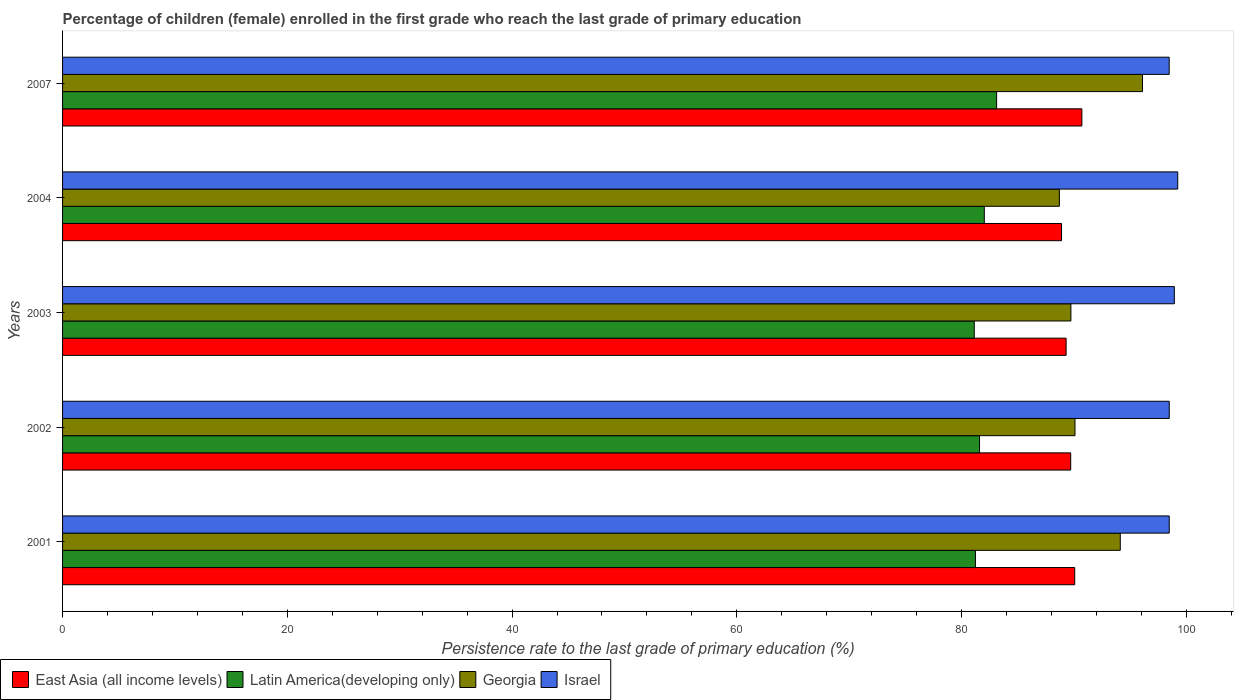How many different coloured bars are there?
Provide a short and direct response. 4. What is the persistence rate of children in Georgia in 2002?
Give a very brief answer. 90.1. Across all years, what is the maximum persistence rate of children in East Asia (all income levels)?
Make the answer very short. 90.71. Across all years, what is the minimum persistence rate of children in Georgia?
Offer a very short reply. 88.71. In which year was the persistence rate of children in Israel maximum?
Ensure brevity in your answer.  2004. What is the total persistence rate of children in Georgia in the graph?
Keep it short and to the point. 458.77. What is the difference between the persistence rate of children in East Asia (all income levels) in 2001 and that in 2003?
Provide a succinct answer. 0.76. What is the difference between the persistence rate of children in Latin America(developing only) in 2003 and the persistence rate of children in Israel in 2002?
Keep it short and to the point. -17.35. What is the average persistence rate of children in East Asia (all income levels) per year?
Ensure brevity in your answer.  89.74. In the year 2004, what is the difference between the persistence rate of children in Latin America(developing only) and persistence rate of children in Georgia?
Ensure brevity in your answer.  -6.68. In how many years, is the persistence rate of children in Georgia greater than 68 %?
Keep it short and to the point. 5. What is the ratio of the persistence rate of children in Latin America(developing only) in 2004 to that in 2007?
Provide a short and direct response. 0.99. Is the difference between the persistence rate of children in Latin America(developing only) in 2002 and 2004 greater than the difference between the persistence rate of children in Georgia in 2002 and 2004?
Make the answer very short. No. What is the difference between the highest and the second highest persistence rate of children in Israel?
Provide a short and direct response. 0.3. What is the difference between the highest and the lowest persistence rate of children in Israel?
Ensure brevity in your answer.  0.76. In how many years, is the persistence rate of children in Israel greater than the average persistence rate of children in Israel taken over all years?
Offer a terse response. 2. Is the sum of the persistence rate of children in Georgia in 2001 and 2002 greater than the maximum persistence rate of children in Latin America(developing only) across all years?
Offer a terse response. Yes. Is it the case that in every year, the sum of the persistence rate of children in Latin America(developing only) and persistence rate of children in Israel is greater than the sum of persistence rate of children in Georgia and persistence rate of children in East Asia (all income levels)?
Offer a very short reply. Yes. What does the 2nd bar from the top in 2004 represents?
Your response must be concise. Georgia. What does the 1st bar from the bottom in 2002 represents?
Your response must be concise. East Asia (all income levels). Is it the case that in every year, the sum of the persistence rate of children in East Asia (all income levels) and persistence rate of children in Israel is greater than the persistence rate of children in Georgia?
Keep it short and to the point. Yes. How many bars are there?
Keep it short and to the point. 20. How many years are there in the graph?
Provide a short and direct response. 5. Does the graph contain grids?
Offer a very short reply. No. Where does the legend appear in the graph?
Your response must be concise. Bottom left. What is the title of the graph?
Your answer should be very brief. Percentage of children (female) enrolled in the first grade who reach the last grade of primary education. What is the label or title of the X-axis?
Provide a short and direct response. Persistence rate to the last grade of primary education (%). What is the Persistence rate to the last grade of primary education (%) in East Asia (all income levels) in 2001?
Ensure brevity in your answer.  90.07. What is the Persistence rate to the last grade of primary education (%) of Latin America(developing only) in 2001?
Give a very brief answer. 81.24. What is the Persistence rate to the last grade of primary education (%) in Georgia in 2001?
Your answer should be very brief. 94.13. What is the Persistence rate to the last grade of primary education (%) of Israel in 2001?
Offer a terse response. 98.48. What is the Persistence rate to the last grade of primary education (%) in East Asia (all income levels) in 2002?
Your answer should be very brief. 89.71. What is the Persistence rate to the last grade of primary education (%) in Latin America(developing only) in 2002?
Your answer should be very brief. 81.6. What is the Persistence rate to the last grade of primary education (%) of Georgia in 2002?
Your response must be concise. 90.1. What is the Persistence rate to the last grade of primary education (%) of Israel in 2002?
Your response must be concise. 98.48. What is the Persistence rate to the last grade of primary education (%) of East Asia (all income levels) in 2003?
Ensure brevity in your answer.  89.31. What is the Persistence rate to the last grade of primary education (%) in Latin America(developing only) in 2003?
Your answer should be compact. 81.13. What is the Persistence rate to the last grade of primary education (%) of Georgia in 2003?
Your answer should be very brief. 89.73. What is the Persistence rate to the last grade of primary education (%) in Israel in 2003?
Give a very brief answer. 98.94. What is the Persistence rate to the last grade of primary education (%) in East Asia (all income levels) in 2004?
Keep it short and to the point. 88.9. What is the Persistence rate to the last grade of primary education (%) in Latin America(developing only) in 2004?
Provide a succinct answer. 82.03. What is the Persistence rate to the last grade of primary education (%) in Georgia in 2004?
Offer a terse response. 88.71. What is the Persistence rate to the last grade of primary education (%) in Israel in 2004?
Your response must be concise. 99.24. What is the Persistence rate to the last grade of primary education (%) in East Asia (all income levels) in 2007?
Give a very brief answer. 90.71. What is the Persistence rate to the last grade of primary education (%) of Latin America(developing only) in 2007?
Make the answer very short. 83.12. What is the Persistence rate to the last grade of primary education (%) of Georgia in 2007?
Your response must be concise. 96.1. What is the Persistence rate to the last grade of primary education (%) of Israel in 2007?
Provide a succinct answer. 98.48. Across all years, what is the maximum Persistence rate to the last grade of primary education (%) of East Asia (all income levels)?
Provide a succinct answer. 90.71. Across all years, what is the maximum Persistence rate to the last grade of primary education (%) of Latin America(developing only)?
Your answer should be very brief. 83.12. Across all years, what is the maximum Persistence rate to the last grade of primary education (%) of Georgia?
Provide a succinct answer. 96.1. Across all years, what is the maximum Persistence rate to the last grade of primary education (%) in Israel?
Offer a very short reply. 99.24. Across all years, what is the minimum Persistence rate to the last grade of primary education (%) of East Asia (all income levels)?
Your answer should be compact. 88.9. Across all years, what is the minimum Persistence rate to the last grade of primary education (%) in Latin America(developing only)?
Keep it short and to the point. 81.13. Across all years, what is the minimum Persistence rate to the last grade of primary education (%) of Georgia?
Your answer should be compact. 88.71. Across all years, what is the minimum Persistence rate to the last grade of primary education (%) of Israel?
Provide a short and direct response. 98.48. What is the total Persistence rate to the last grade of primary education (%) in East Asia (all income levels) in the graph?
Keep it short and to the point. 448.7. What is the total Persistence rate to the last grade of primary education (%) of Latin America(developing only) in the graph?
Ensure brevity in your answer.  409.12. What is the total Persistence rate to the last grade of primary education (%) of Georgia in the graph?
Your answer should be very brief. 458.77. What is the total Persistence rate to the last grade of primary education (%) of Israel in the graph?
Your response must be concise. 493.62. What is the difference between the Persistence rate to the last grade of primary education (%) in East Asia (all income levels) in 2001 and that in 2002?
Provide a succinct answer. 0.36. What is the difference between the Persistence rate to the last grade of primary education (%) in Latin America(developing only) in 2001 and that in 2002?
Keep it short and to the point. -0.36. What is the difference between the Persistence rate to the last grade of primary education (%) of Georgia in 2001 and that in 2002?
Your answer should be very brief. 4.03. What is the difference between the Persistence rate to the last grade of primary education (%) of Israel in 2001 and that in 2002?
Provide a short and direct response. -0. What is the difference between the Persistence rate to the last grade of primary education (%) of East Asia (all income levels) in 2001 and that in 2003?
Your response must be concise. 0.76. What is the difference between the Persistence rate to the last grade of primary education (%) of Latin America(developing only) in 2001 and that in 2003?
Your answer should be very brief. 0.1. What is the difference between the Persistence rate to the last grade of primary education (%) in Georgia in 2001 and that in 2003?
Keep it short and to the point. 4.39. What is the difference between the Persistence rate to the last grade of primary education (%) in Israel in 2001 and that in 2003?
Provide a short and direct response. -0.45. What is the difference between the Persistence rate to the last grade of primary education (%) in East Asia (all income levels) in 2001 and that in 2004?
Give a very brief answer. 1.17. What is the difference between the Persistence rate to the last grade of primary education (%) in Latin America(developing only) in 2001 and that in 2004?
Provide a short and direct response. -0.79. What is the difference between the Persistence rate to the last grade of primary education (%) in Georgia in 2001 and that in 2004?
Make the answer very short. 5.42. What is the difference between the Persistence rate to the last grade of primary education (%) of Israel in 2001 and that in 2004?
Your answer should be very brief. -0.76. What is the difference between the Persistence rate to the last grade of primary education (%) of East Asia (all income levels) in 2001 and that in 2007?
Your response must be concise. -0.64. What is the difference between the Persistence rate to the last grade of primary education (%) in Latin America(developing only) in 2001 and that in 2007?
Your answer should be very brief. -1.88. What is the difference between the Persistence rate to the last grade of primary education (%) in Georgia in 2001 and that in 2007?
Offer a very short reply. -1.98. What is the difference between the Persistence rate to the last grade of primary education (%) in Israel in 2001 and that in 2007?
Provide a short and direct response. 0. What is the difference between the Persistence rate to the last grade of primary education (%) in East Asia (all income levels) in 2002 and that in 2003?
Ensure brevity in your answer.  0.41. What is the difference between the Persistence rate to the last grade of primary education (%) of Latin America(developing only) in 2002 and that in 2003?
Your answer should be compact. 0.47. What is the difference between the Persistence rate to the last grade of primary education (%) of Georgia in 2002 and that in 2003?
Ensure brevity in your answer.  0.36. What is the difference between the Persistence rate to the last grade of primary education (%) of Israel in 2002 and that in 2003?
Ensure brevity in your answer.  -0.45. What is the difference between the Persistence rate to the last grade of primary education (%) of East Asia (all income levels) in 2002 and that in 2004?
Offer a terse response. 0.82. What is the difference between the Persistence rate to the last grade of primary education (%) of Latin America(developing only) in 2002 and that in 2004?
Offer a terse response. -0.43. What is the difference between the Persistence rate to the last grade of primary education (%) of Georgia in 2002 and that in 2004?
Offer a very short reply. 1.39. What is the difference between the Persistence rate to the last grade of primary education (%) of Israel in 2002 and that in 2004?
Your answer should be compact. -0.75. What is the difference between the Persistence rate to the last grade of primary education (%) of East Asia (all income levels) in 2002 and that in 2007?
Ensure brevity in your answer.  -0.99. What is the difference between the Persistence rate to the last grade of primary education (%) of Latin America(developing only) in 2002 and that in 2007?
Make the answer very short. -1.52. What is the difference between the Persistence rate to the last grade of primary education (%) in Georgia in 2002 and that in 2007?
Ensure brevity in your answer.  -6.01. What is the difference between the Persistence rate to the last grade of primary education (%) of Israel in 2002 and that in 2007?
Provide a short and direct response. 0. What is the difference between the Persistence rate to the last grade of primary education (%) in East Asia (all income levels) in 2003 and that in 2004?
Provide a short and direct response. 0.41. What is the difference between the Persistence rate to the last grade of primary education (%) in Latin America(developing only) in 2003 and that in 2004?
Offer a very short reply. -0.89. What is the difference between the Persistence rate to the last grade of primary education (%) in Georgia in 2003 and that in 2004?
Your answer should be compact. 1.03. What is the difference between the Persistence rate to the last grade of primary education (%) of Israel in 2003 and that in 2004?
Your answer should be very brief. -0.3. What is the difference between the Persistence rate to the last grade of primary education (%) in East Asia (all income levels) in 2003 and that in 2007?
Make the answer very short. -1.4. What is the difference between the Persistence rate to the last grade of primary education (%) of Latin America(developing only) in 2003 and that in 2007?
Offer a very short reply. -1.99. What is the difference between the Persistence rate to the last grade of primary education (%) of Georgia in 2003 and that in 2007?
Your answer should be compact. -6.37. What is the difference between the Persistence rate to the last grade of primary education (%) in Israel in 2003 and that in 2007?
Your answer should be compact. 0.46. What is the difference between the Persistence rate to the last grade of primary education (%) of East Asia (all income levels) in 2004 and that in 2007?
Provide a short and direct response. -1.81. What is the difference between the Persistence rate to the last grade of primary education (%) of Latin America(developing only) in 2004 and that in 2007?
Provide a succinct answer. -1.09. What is the difference between the Persistence rate to the last grade of primary education (%) in Georgia in 2004 and that in 2007?
Provide a succinct answer. -7.4. What is the difference between the Persistence rate to the last grade of primary education (%) of Israel in 2004 and that in 2007?
Your response must be concise. 0.76. What is the difference between the Persistence rate to the last grade of primary education (%) of East Asia (all income levels) in 2001 and the Persistence rate to the last grade of primary education (%) of Latin America(developing only) in 2002?
Give a very brief answer. 8.47. What is the difference between the Persistence rate to the last grade of primary education (%) of East Asia (all income levels) in 2001 and the Persistence rate to the last grade of primary education (%) of Georgia in 2002?
Offer a terse response. -0.03. What is the difference between the Persistence rate to the last grade of primary education (%) in East Asia (all income levels) in 2001 and the Persistence rate to the last grade of primary education (%) in Israel in 2002?
Provide a short and direct response. -8.41. What is the difference between the Persistence rate to the last grade of primary education (%) in Latin America(developing only) in 2001 and the Persistence rate to the last grade of primary education (%) in Georgia in 2002?
Your answer should be compact. -8.86. What is the difference between the Persistence rate to the last grade of primary education (%) of Latin America(developing only) in 2001 and the Persistence rate to the last grade of primary education (%) of Israel in 2002?
Your answer should be very brief. -17.25. What is the difference between the Persistence rate to the last grade of primary education (%) in Georgia in 2001 and the Persistence rate to the last grade of primary education (%) in Israel in 2002?
Give a very brief answer. -4.36. What is the difference between the Persistence rate to the last grade of primary education (%) in East Asia (all income levels) in 2001 and the Persistence rate to the last grade of primary education (%) in Latin America(developing only) in 2003?
Offer a terse response. 8.94. What is the difference between the Persistence rate to the last grade of primary education (%) of East Asia (all income levels) in 2001 and the Persistence rate to the last grade of primary education (%) of Georgia in 2003?
Provide a succinct answer. 0.34. What is the difference between the Persistence rate to the last grade of primary education (%) of East Asia (all income levels) in 2001 and the Persistence rate to the last grade of primary education (%) of Israel in 2003?
Make the answer very short. -8.87. What is the difference between the Persistence rate to the last grade of primary education (%) in Latin America(developing only) in 2001 and the Persistence rate to the last grade of primary education (%) in Georgia in 2003?
Offer a terse response. -8.49. What is the difference between the Persistence rate to the last grade of primary education (%) of Latin America(developing only) in 2001 and the Persistence rate to the last grade of primary education (%) of Israel in 2003?
Your response must be concise. -17.7. What is the difference between the Persistence rate to the last grade of primary education (%) in Georgia in 2001 and the Persistence rate to the last grade of primary education (%) in Israel in 2003?
Provide a short and direct response. -4.81. What is the difference between the Persistence rate to the last grade of primary education (%) of East Asia (all income levels) in 2001 and the Persistence rate to the last grade of primary education (%) of Latin America(developing only) in 2004?
Provide a short and direct response. 8.04. What is the difference between the Persistence rate to the last grade of primary education (%) in East Asia (all income levels) in 2001 and the Persistence rate to the last grade of primary education (%) in Georgia in 2004?
Provide a succinct answer. 1.36. What is the difference between the Persistence rate to the last grade of primary education (%) in East Asia (all income levels) in 2001 and the Persistence rate to the last grade of primary education (%) in Israel in 2004?
Provide a short and direct response. -9.17. What is the difference between the Persistence rate to the last grade of primary education (%) of Latin America(developing only) in 2001 and the Persistence rate to the last grade of primary education (%) of Georgia in 2004?
Make the answer very short. -7.47. What is the difference between the Persistence rate to the last grade of primary education (%) in Latin America(developing only) in 2001 and the Persistence rate to the last grade of primary education (%) in Israel in 2004?
Your answer should be compact. -18. What is the difference between the Persistence rate to the last grade of primary education (%) in Georgia in 2001 and the Persistence rate to the last grade of primary education (%) in Israel in 2004?
Give a very brief answer. -5.11. What is the difference between the Persistence rate to the last grade of primary education (%) of East Asia (all income levels) in 2001 and the Persistence rate to the last grade of primary education (%) of Latin America(developing only) in 2007?
Give a very brief answer. 6.95. What is the difference between the Persistence rate to the last grade of primary education (%) in East Asia (all income levels) in 2001 and the Persistence rate to the last grade of primary education (%) in Georgia in 2007?
Offer a terse response. -6.03. What is the difference between the Persistence rate to the last grade of primary education (%) of East Asia (all income levels) in 2001 and the Persistence rate to the last grade of primary education (%) of Israel in 2007?
Keep it short and to the point. -8.41. What is the difference between the Persistence rate to the last grade of primary education (%) of Latin America(developing only) in 2001 and the Persistence rate to the last grade of primary education (%) of Georgia in 2007?
Keep it short and to the point. -14.87. What is the difference between the Persistence rate to the last grade of primary education (%) of Latin America(developing only) in 2001 and the Persistence rate to the last grade of primary education (%) of Israel in 2007?
Make the answer very short. -17.24. What is the difference between the Persistence rate to the last grade of primary education (%) in Georgia in 2001 and the Persistence rate to the last grade of primary education (%) in Israel in 2007?
Your answer should be compact. -4.35. What is the difference between the Persistence rate to the last grade of primary education (%) in East Asia (all income levels) in 2002 and the Persistence rate to the last grade of primary education (%) in Latin America(developing only) in 2003?
Offer a very short reply. 8.58. What is the difference between the Persistence rate to the last grade of primary education (%) of East Asia (all income levels) in 2002 and the Persistence rate to the last grade of primary education (%) of Georgia in 2003?
Provide a succinct answer. -0.02. What is the difference between the Persistence rate to the last grade of primary education (%) in East Asia (all income levels) in 2002 and the Persistence rate to the last grade of primary education (%) in Israel in 2003?
Your response must be concise. -9.22. What is the difference between the Persistence rate to the last grade of primary education (%) in Latin America(developing only) in 2002 and the Persistence rate to the last grade of primary education (%) in Georgia in 2003?
Make the answer very short. -8.13. What is the difference between the Persistence rate to the last grade of primary education (%) of Latin America(developing only) in 2002 and the Persistence rate to the last grade of primary education (%) of Israel in 2003?
Provide a short and direct response. -17.34. What is the difference between the Persistence rate to the last grade of primary education (%) in Georgia in 2002 and the Persistence rate to the last grade of primary education (%) in Israel in 2003?
Your answer should be compact. -8.84. What is the difference between the Persistence rate to the last grade of primary education (%) in East Asia (all income levels) in 2002 and the Persistence rate to the last grade of primary education (%) in Latin America(developing only) in 2004?
Your response must be concise. 7.69. What is the difference between the Persistence rate to the last grade of primary education (%) in East Asia (all income levels) in 2002 and the Persistence rate to the last grade of primary education (%) in Georgia in 2004?
Provide a succinct answer. 1.01. What is the difference between the Persistence rate to the last grade of primary education (%) in East Asia (all income levels) in 2002 and the Persistence rate to the last grade of primary education (%) in Israel in 2004?
Give a very brief answer. -9.53. What is the difference between the Persistence rate to the last grade of primary education (%) of Latin America(developing only) in 2002 and the Persistence rate to the last grade of primary education (%) of Georgia in 2004?
Your answer should be compact. -7.11. What is the difference between the Persistence rate to the last grade of primary education (%) of Latin America(developing only) in 2002 and the Persistence rate to the last grade of primary education (%) of Israel in 2004?
Provide a short and direct response. -17.64. What is the difference between the Persistence rate to the last grade of primary education (%) in Georgia in 2002 and the Persistence rate to the last grade of primary education (%) in Israel in 2004?
Your response must be concise. -9.14. What is the difference between the Persistence rate to the last grade of primary education (%) of East Asia (all income levels) in 2002 and the Persistence rate to the last grade of primary education (%) of Latin America(developing only) in 2007?
Make the answer very short. 6.59. What is the difference between the Persistence rate to the last grade of primary education (%) of East Asia (all income levels) in 2002 and the Persistence rate to the last grade of primary education (%) of Georgia in 2007?
Make the answer very short. -6.39. What is the difference between the Persistence rate to the last grade of primary education (%) in East Asia (all income levels) in 2002 and the Persistence rate to the last grade of primary education (%) in Israel in 2007?
Offer a terse response. -8.77. What is the difference between the Persistence rate to the last grade of primary education (%) of Latin America(developing only) in 2002 and the Persistence rate to the last grade of primary education (%) of Georgia in 2007?
Give a very brief answer. -14.5. What is the difference between the Persistence rate to the last grade of primary education (%) of Latin America(developing only) in 2002 and the Persistence rate to the last grade of primary education (%) of Israel in 2007?
Your response must be concise. -16.88. What is the difference between the Persistence rate to the last grade of primary education (%) of Georgia in 2002 and the Persistence rate to the last grade of primary education (%) of Israel in 2007?
Your response must be concise. -8.38. What is the difference between the Persistence rate to the last grade of primary education (%) of East Asia (all income levels) in 2003 and the Persistence rate to the last grade of primary education (%) of Latin America(developing only) in 2004?
Your response must be concise. 7.28. What is the difference between the Persistence rate to the last grade of primary education (%) in East Asia (all income levels) in 2003 and the Persistence rate to the last grade of primary education (%) in Georgia in 2004?
Your response must be concise. 0.6. What is the difference between the Persistence rate to the last grade of primary education (%) in East Asia (all income levels) in 2003 and the Persistence rate to the last grade of primary education (%) in Israel in 2004?
Offer a terse response. -9.93. What is the difference between the Persistence rate to the last grade of primary education (%) in Latin America(developing only) in 2003 and the Persistence rate to the last grade of primary education (%) in Georgia in 2004?
Give a very brief answer. -7.57. What is the difference between the Persistence rate to the last grade of primary education (%) of Latin America(developing only) in 2003 and the Persistence rate to the last grade of primary education (%) of Israel in 2004?
Ensure brevity in your answer.  -18.11. What is the difference between the Persistence rate to the last grade of primary education (%) of Georgia in 2003 and the Persistence rate to the last grade of primary education (%) of Israel in 2004?
Offer a very short reply. -9.51. What is the difference between the Persistence rate to the last grade of primary education (%) of East Asia (all income levels) in 2003 and the Persistence rate to the last grade of primary education (%) of Latin America(developing only) in 2007?
Provide a short and direct response. 6.18. What is the difference between the Persistence rate to the last grade of primary education (%) in East Asia (all income levels) in 2003 and the Persistence rate to the last grade of primary education (%) in Georgia in 2007?
Offer a very short reply. -6.8. What is the difference between the Persistence rate to the last grade of primary education (%) of East Asia (all income levels) in 2003 and the Persistence rate to the last grade of primary education (%) of Israel in 2007?
Keep it short and to the point. -9.17. What is the difference between the Persistence rate to the last grade of primary education (%) of Latin America(developing only) in 2003 and the Persistence rate to the last grade of primary education (%) of Georgia in 2007?
Your response must be concise. -14.97. What is the difference between the Persistence rate to the last grade of primary education (%) in Latin America(developing only) in 2003 and the Persistence rate to the last grade of primary education (%) in Israel in 2007?
Provide a succinct answer. -17.35. What is the difference between the Persistence rate to the last grade of primary education (%) of Georgia in 2003 and the Persistence rate to the last grade of primary education (%) of Israel in 2007?
Offer a terse response. -8.75. What is the difference between the Persistence rate to the last grade of primary education (%) in East Asia (all income levels) in 2004 and the Persistence rate to the last grade of primary education (%) in Latin America(developing only) in 2007?
Your answer should be very brief. 5.78. What is the difference between the Persistence rate to the last grade of primary education (%) of East Asia (all income levels) in 2004 and the Persistence rate to the last grade of primary education (%) of Georgia in 2007?
Your answer should be very brief. -7.21. What is the difference between the Persistence rate to the last grade of primary education (%) of East Asia (all income levels) in 2004 and the Persistence rate to the last grade of primary education (%) of Israel in 2007?
Provide a short and direct response. -9.58. What is the difference between the Persistence rate to the last grade of primary education (%) in Latin America(developing only) in 2004 and the Persistence rate to the last grade of primary education (%) in Georgia in 2007?
Keep it short and to the point. -14.08. What is the difference between the Persistence rate to the last grade of primary education (%) in Latin America(developing only) in 2004 and the Persistence rate to the last grade of primary education (%) in Israel in 2007?
Make the answer very short. -16.45. What is the difference between the Persistence rate to the last grade of primary education (%) in Georgia in 2004 and the Persistence rate to the last grade of primary education (%) in Israel in 2007?
Ensure brevity in your answer.  -9.77. What is the average Persistence rate to the last grade of primary education (%) of East Asia (all income levels) per year?
Offer a very short reply. 89.74. What is the average Persistence rate to the last grade of primary education (%) of Latin America(developing only) per year?
Offer a terse response. 81.82. What is the average Persistence rate to the last grade of primary education (%) in Georgia per year?
Give a very brief answer. 91.75. What is the average Persistence rate to the last grade of primary education (%) in Israel per year?
Provide a short and direct response. 98.72. In the year 2001, what is the difference between the Persistence rate to the last grade of primary education (%) in East Asia (all income levels) and Persistence rate to the last grade of primary education (%) in Latin America(developing only)?
Your answer should be very brief. 8.83. In the year 2001, what is the difference between the Persistence rate to the last grade of primary education (%) of East Asia (all income levels) and Persistence rate to the last grade of primary education (%) of Georgia?
Provide a succinct answer. -4.06. In the year 2001, what is the difference between the Persistence rate to the last grade of primary education (%) in East Asia (all income levels) and Persistence rate to the last grade of primary education (%) in Israel?
Provide a succinct answer. -8.41. In the year 2001, what is the difference between the Persistence rate to the last grade of primary education (%) of Latin America(developing only) and Persistence rate to the last grade of primary education (%) of Georgia?
Ensure brevity in your answer.  -12.89. In the year 2001, what is the difference between the Persistence rate to the last grade of primary education (%) in Latin America(developing only) and Persistence rate to the last grade of primary education (%) in Israel?
Keep it short and to the point. -17.25. In the year 2001, what is the difference between the Persistence rate to the last grade of primary education (%) in Georgia and Persistence rate to the last grade of primary education (%) in Israel?
Provide a short and direct response. -4.36. In the year 2002, what is the difference between the Persistence rate to the last grade of primary education (%) in East Asia (all income levels) and Persistence rate to the last grade of primary education (%) in Latin America(developing only)?
Offer a very short reply. 8.11. In the year 2002, what is the difference between the Persistence rate to the last grade of primary education (%) of East Asia (all income levels) and Persistence rate to the last grade of primary education (%) of Georgia?
Your answer should be compact. -0.38. In the year 2002, what is the difference between the Persistence rate to the last grade of primary education (%) of East Asia (all income levels) and Persistence rate to the last grade of primary education (%) of Israel?
Your answer should be very brief. -8.77. In the year 2002, what is the difference between the Persistence rate to the last grade of primary education (%) of Latin America(developing only) and Persistence rate to the last grade of primary education (%) of Georgia?
Provide a succinct answer. -8.49. In the year 2002, what is the difference between the Persistence rate to the last grade of primary education (%) in Latin America(developing only) and Persistence rate to the last grade of primary education (%) in Israel?
Keep it short and to the point. -16.88. In the year 2002, what is the difference between the Persistence rate to the last grade of primary education (%) of Georgia and Persistence rate to the last grade of primary education (%) of Israel?
Your answer should be compact. -8.39. In the year 2003, what is the difference between the Persistence rate to the last grade of primary education (%) of East Asia (all income levels) and Persistence rate to the last grade of primary education (%) of Latin America(developing only)?
Your response must be concise. 8.17. In the year 2003, what is the difference between the Persistence rate to the last grade of primary education (%) of East Asia (all income levels) and Persistence rate to the last grade of primary education (%) of Georgia?
Provide a succinct answer. -0.43. In the year 2003, what is the difference between the Persistence rate to the last grade of primary education (%) in East Asia (all income levels) and Persistence rate to the last grade of primary education (%) in Israel?
Your response must be concise. -9.63. In the year 2003, what is the difference between the Persistence rate to the last grade of primary education (%) in Latin America(developing only) and Persistence rate to the last grade of primary education (%) in Georgia?
Make the answer very short. -8.6. In the year 2003, what is the difference between the Persistence rate to the last grade of primary education (%) of Latin America(developing only) and Persistence rate to the last grade of primary education (%) of Israel?
Provide a succinct answer. -17.8. In the year 2003, what is the difference between the Persistence rate to the last grade of primary education (%) of Georgia and Persistence rate to the last grade of primary education (%) of Israel?
Offer a terse response. -9.21. In the year 2004, what is the difference between the Persistence rate to the last grade of primary education (%) of East Asia (all income levels) and Persistence rate to the last grade of primary education (%) of Latin America(developing only)?
Give a very brief answer. 6.87. In the year 2004, what is the difference between the Persistence rate to the last grade of primary education (%) of East Asia (all income levels) and Persistence rate to the last grade of primary education (%) of Georgia?
Provide a succinct answer. 0.19. In the year 2004, what is the difference between the Persistence rate to the last grade of primary education (%) of East Asia (all income levels) and Persistence rate to the last grade of primary education (%) of Israel?
Give a very brief answer. -10.34. In the year 2004, what is the difference between the Persistence rate to the last grade of primary education (%) of Latin America(developing only) and Persistence rate to the last grade of primary education (%) of Georgia?
Your answer should be very brief. -6.68. In the year 2004, what is the difference between the Persistence rate to the last grade of primary education (%) of Latin America(developing only) and Persistence rate to the last grade of primary education (%) of Israel?
Your response must be concise. -17.21. In the year 2004, what is the difference between the Persistence rate to the last grade of primary education (%) of Georgia and Persistence rate to the last grade of primary education (%) of Israel?
Make the answer very short. -10.53. In the year 2007, what is the difference between the Persistence rate to the last grade of primary education (%) of East Asia (all income levels) and Persistence rate to the last grade of primary education (%) of Latin America(developing only)?
Your answer should be very brief. 7.59. In the year 2007, what is the difference between the Persistence rate to the last grade of primary education (%) in East Asia (all income levels) and Persistence rate to the last grade of primary education (%) in Georgia?
Ensure brevity in your answer.  -5.4. In the year 2007, what is the difference between the Persistence rate to the last grade of primary education (%) in East Asia (all income levels) and Persistence rate to the last grade of primary education (%) in Israel?
Give a very brief answer. -7.77. In the year 2007, what is the difference between the Persistence rate to the last grade of primary education (%) in Latin America(developing only) and Persistence rate to the last grade of primary education (%) in Georgia?
Your response must be concise. -12.98. In the year 2007, what is the difference between the Persistence rate to the last grade of primary education (%) of Latin America(developing only) and Persistence rate to the last grade of primary education (%) of Israel?
Make the answer very short. -15.36. In the year 2007, what is the difference between the Persistence rate to the last grade of primary education (%) of Georgia and Persistence rate to the last grade of primary education (%) of Israel?
Provide a succinct answer. -2.38. What is the ratio of the Persistence rate to the last grade of primary education (%) in Latin America(developing only) in 2001 to that in 2002?
Give a very brief answer. 1. What is the ratio of the Persistence rate to the last grade of primary education (%) in Georgia in 2001 to that in 2002?
Offer a very short reply. 1.04. What is the ratio of the Persistence rate to the last grade of primary education (%) of Israel in 2001 to that in 2002?
Offer a very short reply. 1. What is the ratio of the Persistence rate to the last grade of primary education (%) of East Asia (all income levels) in 2001 to that in 2003?
Keep it short and to the point. 1.01. What is the ratio of the Persistence rate to the last grade of primary education (%) of Georgia in 2001 to that in 2003?
Make the answer very short. 1.05. What is the ratio of the Persistence rate to the last grade of primary education (%) of Israel in 2001 to that in 2003?
Give a very brief answer. 1. What is the ratio of the Persistence rate to the last grade of primary education (%) in East Asia (all income levels) in 2001 to that in 2004?
Give a very brief answer. 1.01. What is the ratio of the Persistence rate to the last grade of primary education (%) of Georgia in 2001 to that in 2004?
Make the answer very short. 1.06. What is the ratio of the Persistence rate to the last grade of primary education (%) in Israel in 2001 to that in 2004?
Keep it short and to the point. 0.99. What is the ratio of the Persistence rate to the last grade of primary education (%) of Latin America(developing only) in 2001 to that in 2007?
Your answer should be very brief. 0.98. What is the ratio of the Persistence rate to the last grade of primary education (%) in Georgia in 2001 to that in 2007?
Offer a very short reply. 0.98. What is the ratio of the Persistence rate to the last grade of primary education (%) in East Asia (all income levels) in 2002 to that in 2003?
Give a very brief answer. 1. What is the ratio of the Persistence rate to the last grade of primary education (%) in Latin America(developing only) in 2002 to that in 2003?
Offer a terse response. 1.01. What is the ratio of the Persistence rate to the last grade of primary education (%) of Georgia in 2002 to that in 2003?
Your answer should be compact. 1. What is the ratio of the Persistence rate to the last grade of primary education (%) of East Asia (all income levels) in 2002 to that in 2004?
Your response must be concise. 1.01. What is the ratio of the Persistence rate to the last grade of primary education (%) in Georgia in 2002 to that in 2004?
Make the answer very short. 1.02. What is the ratio of the Persistence rate to the last grade of primary education (%) in Israel in 2002 to that in 2004?
Provide a succinct answer. 0.99. What is the ratio of the Persistence rate to the last grade of primary education (%) of Latin America(developing only) in 2002 to that in 2007?
Your answer should be compact. 0.98. What is the ratio of the Persistence rate to the last grade of primary education (%) in Georgia in 2002 to that in 2007?
Provide a short and direct response. 0.94. What is the ratio of the Persistence rate to the last grade of primary education (%) in Israel in 2002 to that in 2007?
Offer a very short reply. 1. What is the ratio of the Persistence rate to the last grade of primary education (%) of East Asia (all income levels) in 2003 to that in 2004?
Provide a short and direct response. 1. What is the ratio of the Persistence rate to the last grade of primary education (%) of Georgia in 2003 to that in 2004?
Provide a short and direct response. 1.01. What is the ratio of the Persistence rate to the last grade of primary education (%) in Israel in 2003 to that in 2004?
Your answer should be compact. 1. What is the ratio of the Persistence rate to the last grade of primary education (%) in East Asia (all income levels) in 2003 to that in 2007?
Provide a short and direct response. 0.98. What is the ratio of the Persistence rate to the last grade of primary education (%) in Latin America(developing only) in 2003 to that in 2007?
Give a very brief answer. 0.98. What is the ratio of the Persistence rate to the last grade of primary education (%) of Georgia in 2003 to that in 2007?
Your answer should be very brief. 0.93. What is the ratio of the Persistence rate to the last grade of primary education (%) in East Asia (all income levels) in 2004 to that in 2007?
Your answer should be very brief. 0.98. What is the ratio of the Persistence rate to the last grade of primary education (%) of Georgia in 2004 to that in 2007?
Provide a short and direct response. 0.92. What is the ratio of the Persistence rate to the last grade of primary education (%) of Israel in 2004 to that in 2007?
Provide a succinct answer. 1.01. What is the difference between the highest and the second highest Persistence rate to the last grade of primary education (%) in East Asia (all income levels)?
Provide a short and direct response. 0.64. What is the difference between the highest and the second highest Persistence rate to the last grade of primary education (%) in Latin America(developing only)?
Keep it short and to the point. 1.09. What is the difference between the highest and the second highest Persistence rate to the last grade of primary education (%) in Georgia?
Your answer should be compact. 1.98. What is the difference between the highest and the second highest Persistence rate to the last grade of primary education (%) in Israel?
Ensure brevity in your answer.  0.3. What is the difference between the highest and the lowest Persistence rate to the last grade of primary education (%) of East Asia (all income levels)?
Your answer should be very brief. 1.81. What is the difference between the highest and the lowest Persistence rate to the last grade of primary education (%) in Latin America(developing only)?
Your response must be concise. 1.99. What is the difference between the highest and the lowest Persistence rate to the last grade of primary education (%) of Georgia?
Your answer should be very brief. 7.4. What is the difference between the highest and the lowest Persistence rate to the last grade of primary education (%) in Israel?
Offer a very short reply. 0.76. 